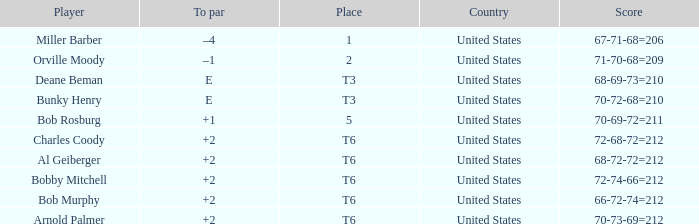What is the to par of player bunky henry? E. 